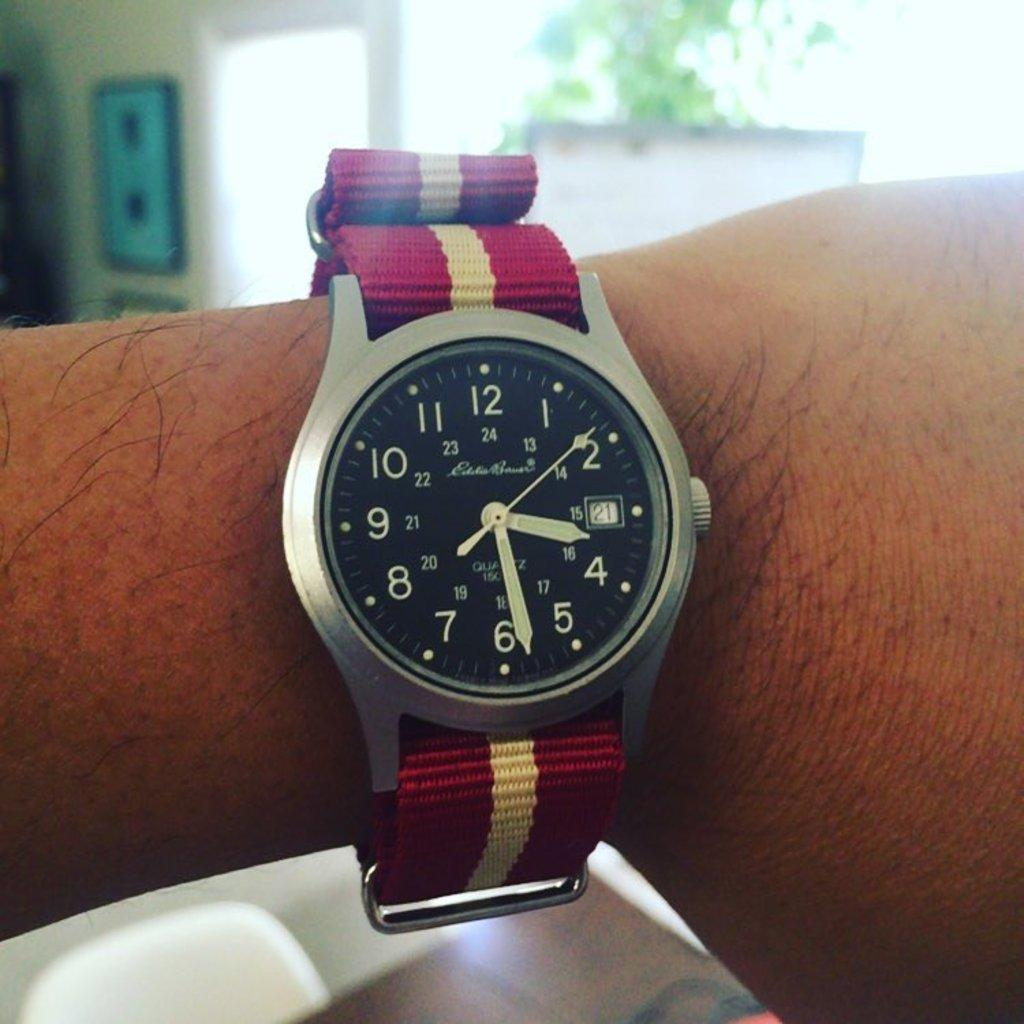<image>
Write a terse but informative summary of the picture. Person wearing a watch which has the hands on the number 4 and 6. 